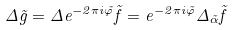<formula> <loc_0><loc_0><loc_500><loc_500>\Delta \tilde { g } = \Delta e ^ { - 2 \pi i \tilde { \varphi } } \tilde { f } = e ^ { - 2 \pi i \tilde { \varphi } } \Delta _ { \tilde { \alpha } } \tilde { f }</formula> 